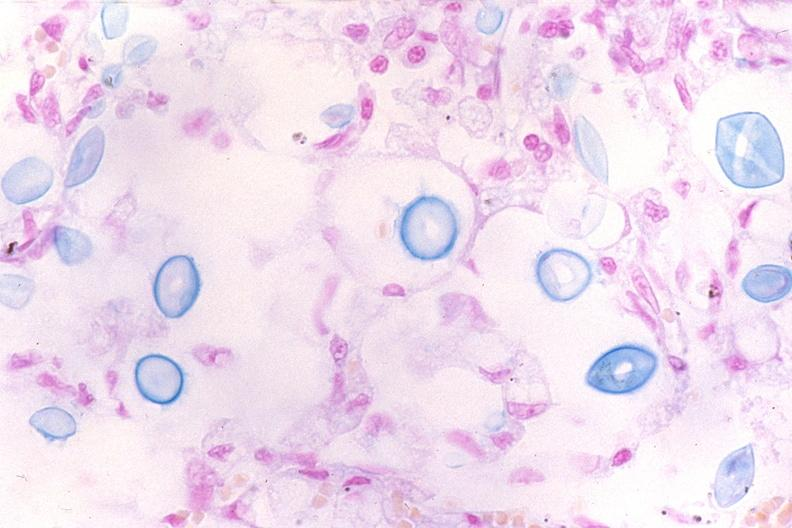what is present?
Answer the question using a single word or phrase. Respiratory 